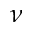Convert formula to latex. <formula><loc_0><loc_0><loc_500><loc_500>\nu</formula> 